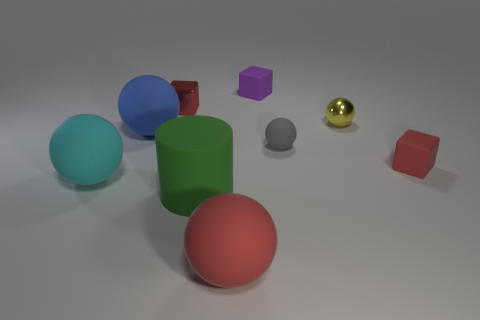What material is the gray ball?
Give a very brief answer. Rubber. Is the number of small yellow balls that are in front of the big green matte cylinder the same as the number of small green metallic cylinders?
Your answer should be very brief. Yes. What number of cyan objects are the same shape as the green object?
Keep it short and to the point. 0. Is the tiny gray matte thing the same shape as the yellow object?
Make the answer very short. Yes. How many objects are either balls that are on the right side of the large cyan object or big cylinders?
Ensure brevity in your answer.  5. What shape is the small red thing that is behind the red thing to the right of the tiny yellow shiny sphere in front of the small purple matte block?
Provide a succinct answer. Cube. What shape is the cyan thing that is the same material as the gray sphere?
Offer a terse response. Sphere. The blue rubber object is what size?
Keep it short and to the point. Large. Do the cyan sphere and the green cylinder have the same size?
Your answer should be very brief. Yes. What number of objects are either rubber spheres that are in front of the large cyan ball or tiny things right of the cylinder?
Your answer should be very brief. 5. 